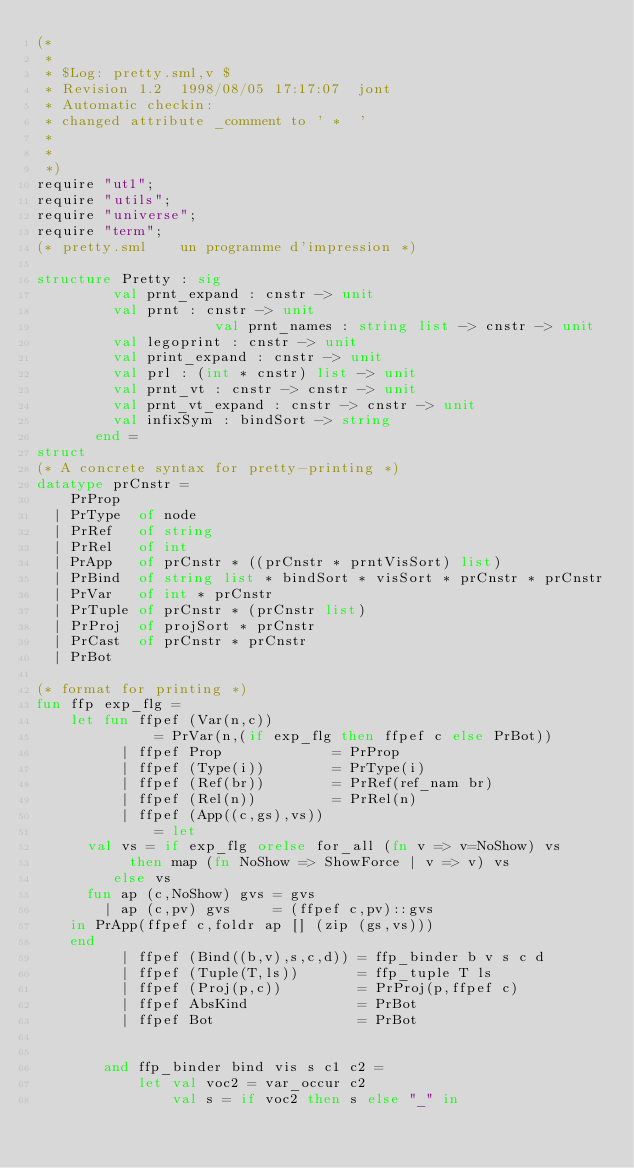<code> <loc_0><loc_0><loc_500><loc_500><_SML_>(*
 *
 * $Log: pretty.sml,v $
 * Revision 1.2  1998/08/05 17:17:07  jont
 * Automatic checkin:
 * changed attribute _comment to ' *  '
 *
 *
 *)
require "ut1";
require "utils";
require "universe";
require "term";
(* pretty.sml    un programme d'impression *)

structure Pretty : sig
		     val prnt_expand : cnstr -> unit
		     val prnt : cnstr -> unit
                     val prnt_names : string list -> cnstr -> unit
		     val legoprint : cnstr -> unit
		     val print_expand : cnstr -> unit
		     val prl : (int * cnstr) list -> unit
		     val prnt_vt : cnstr -> cnstr -> unit
		     val prnt_vt_expand : cnstr -> cnstr -> unit
		     val infixSym : bindSort -> string
		   end =
struct         
(* A concrete syntax for pretty-printing *)
datatype prCnstr =
    PrProp
  | PrType  of node
  | PrRef   of string
  | PrRel   of int
  | PrApp   of prCnstr * ((prCnstr * prntVisSort) list)
  | PrBind  of string list * bindSort * visSort * prCnstr * prCnstr
  | PrVar   of int * prCnstr
  | PrTuple of prCnstr * (prCnstr list)
  | PrProj  of projSort * prCnstr
  | PrCast  of prCnstr * prCnstr
  | PrBot

(* format for printing *)
fun ffp exp_flg = 
    let fun ffpef (Var(n,c))       
              = PrVar(n,(if exp_flg then ffpef c else PrBot))
          | ffpef Prop             = PrProp
          | ffpef (Type(i))        = PrType(i)
          | ffpef (Ref(br))        = PrRef(ref_nam br)
          | ffpef (Rel(n))         = PrRel(n)
          | ffpef (App((c,gs),vs)) 
              = let
		  val vs = if exp_flg orelse for_all (fn v => v=NoShow) vs
			     then map (fn NoShow => ShowForce | v => v) vs
			   else vs
		  fun ap (c,NoShow) gvs = gvs
		    | ap (c,pv) gvs     = (ffpef c,pv)::gvs
		in PrApp(ffpef c,foldr ap [] (zip (gs,vs)))
		end
          | ffpef (Bind((b,v),s,c,d)) = ffp_binder b v s c d
          | ffpef (Tuple(T,ls))       = ffp_tuple T ls
          | ffpef (Proj(p,c))         = PrProj(p,ffpef c)
          | ffpef AbsKind             = PrBot
          | ffpef Bot                 = PrBot


        and ffp_binder bind vis s c1 c2 =
            let val voc2 = var_occur c2 
                val s = if voc2 then s else "_" in</code> 